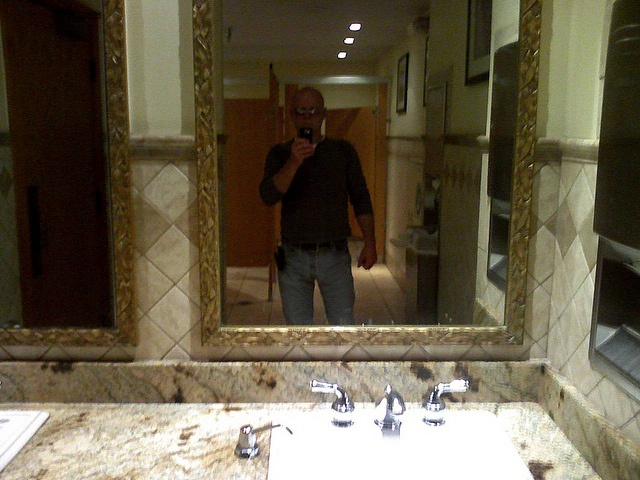Describe the objects in this image and their specific colors. I can see people in black, maroon, and gray tones, sink in black, white, darkgray, and gray tones, sink in black, white, darkgray, and gray tones, and cell phone in black tones in this image. 